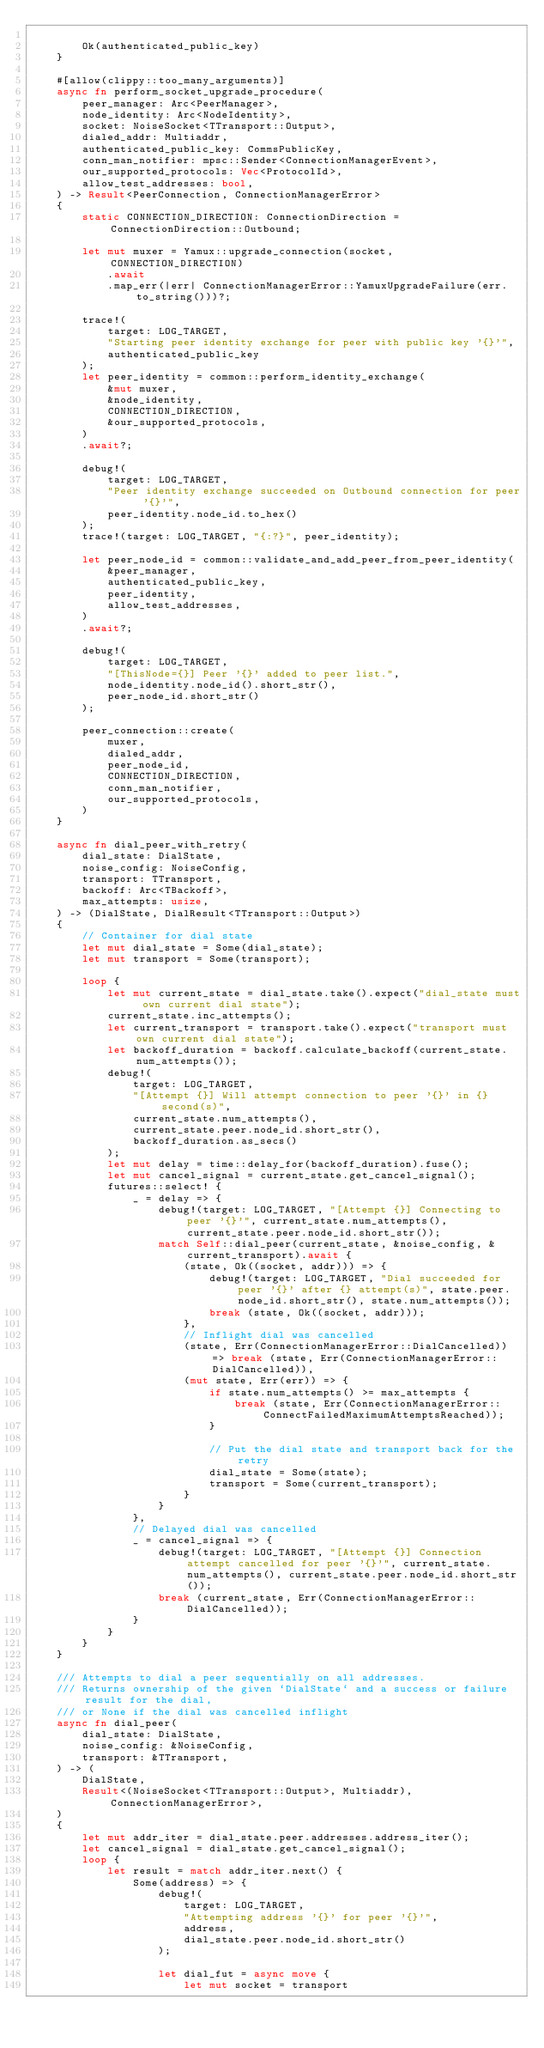<code> <loc_0><loc_0><loc_500><loc_500><_Rust_>
        Ok(authenticated_public_key)
    }

    #[allow(clippy::too_many_arguments)]
    async fn perform_socket_upgrade_procedure(
        peer_manager: Arc<PeerManager>,
        node_identity: Arc<NodeIdentity>,
        socket: NoiseSocket<TTransport::Output>,
        dialed_addr: Multiaddr,
        authenticated_public_key: CommsPublicKey,
        conn_man_notifier: mpsc::Sender<ConnectionManagerEvent>,
        our_supported_protocols: Vec<ProtocolId>,
        allow_test_addresses: bool,
    ) -> Result<PeerConnection, ConnectionManagerError>
    {
        static CONNECTION_DIRECTION: ConnectionDirection = ConnectionDirection::Outbound;

        let mut muxer = Yamux::upgrade_connection(socket, CONNECTION_DIRECTION)
            .await
            .map_err(|err| ConnectionManagerError::YamuxUpgradeFailure(err.to_string()))?;

        trace!(
            target: LOG_TARGET,
            "Starting peer identity exchange for peer with public key '{}'",
            authenticated_public_key
        );
        let peer_identity = common::perform_identity_exchange(
            &mut muxer,
            &node_identity,
            CONNECTION_DIRECTION,
            &our_supported_protocols,
        )
        .await?;

        debug!(
            target: LOG_TARGET,
            "Peer identity exchange succeeded on Outbound connection for peer '{}'",
            peer_identity.node_id.to_hex()
        );
        trace!(target: LOG_TARGET, "{:?}", peer_identity);

        let peer_node_id = common::validate_and_add_peer_from_peer_identity(
            &peer_manager,
            authenticated_public_key,
            peer_identity,
            allow_test_addresses,
        )
        .await?;

        debug!(
            target: LOG_TARGET,
            "[ThisNode={}] Peer '{}' added to peer list.",
            node_identity.node_id().short_str(),
            peer_node_id.short_str()
        );

        peer_connection::create(
            muxer,
            dialed_addr,
            peer_node_id,
            CONNECTION_DIRECTION,
            conn_man_notifier,
            our_supported_protocols,
        )
    }

    async fn dial_peer_with_retry(
        dial_state: DialState,
        noise_config: NoiseConfig,
        transport: TTransport,
        backoff: Arc<TBackoff>,
        max_attempts: usize,
    ) -> (DialState, DialResult<TTransport::Output>)
    {
        // Container for dial state
        let mut dial_state = Some(dial_state);
        let mut transport = Some(transport);

        loop {
            let mut current_state = dial_state.take().expect("dial_state must own current dial state");
            current_state.inc_attempts();
            let current_transport = transport.take().expect("transport must own current dial state");
            let backoff_duration = backoff.calculate_backoff(current_state.num_attempts());
            debug!(
                target: LOG_TARGET,
                "[Attempt {}] Will attempt connection to peer '{}' in {} second(s)",
                current_state.num_attempts(),
                current_state.peer.node_id.short_str(),
                backoff_duration.as_secs()
            );
            let mut delay = time::delay_for(backoff_duration).fuse();
            let mut cancel_signal = current_state.get_cancel_signal();
            futures::select! {
                _ = delay => {
                    debug!(target: LOG_TARGET, "[Attempt {}] Connecting to peer '{}'", current_state.num_attempts(), current_state.peer.node_id.short_str());
                    match Self::dial_peer(current_state, &noise_config, &current_transport).await {
                        (state, Ok((socket, addr))) => {
                            debug!(target: LOG_TARGET, "Dial succeeded for peer '{}' after {} attempt(s)", state.peer.node_id.short_str(), state.num_attempts());
                            break (state, Ok((socket, addr)));
                        },
                        // Inflight dial was cancelled
                        (state, Err(ConnectionManagerError::DialCancelled)) => break (state, Err(ConnectionManagerError::DialCancelled)),
                        (mut state, Err(err)) => {
                            if state.num_attempts() >= max_attempts {
                                break (state, Err(ConnectionManagerError::ConnectFailedMaximumAttemptsReached));
                            }

                            // Put the dial state and transport back for the retry
                            dial_state = Some(state);
                            transport = Some(current_transport);
                        }
                    }
                },
                // Delayed dial was cancelled
                _ = cancel_signal => {
                    debug!(target: LOG_TARGET, "[Attempt {}] Connection attempt cancelled for peer '{}'", current_state.num_attempts(), current_state.peer.node_id.short_str());
                    break (current_state, Err(ConnectionManagerError::DialCancelled));
                }
            }
        }
    }

    /// Attempts to dial a peer sequentially on all addresses.
    /// Returns ownership of the given `DialState` and a success or failure result for the dial,
    /// or None if the dial was cancelled inflight
    async fn dial_peer(
        dial_state: DialState,
        noise_config: &NoiseConfig,
        transport: &TTransport,
    ) -> (
        DialState,
        Result<(NoiseSocket<TTransport::Output>, Multiaddr), ConnectionManagerError>,
    )
    {
        let mut addr_iter = dial_state.peer.addresses.address_iter();
        let cancel_signal = dial_state.get_cancel_signal();
        loop {
            let result = match addr_iter.next() {
                Some(address) => {
                    debug!(
                        target: LOG_TARGET,
                        "Attempting address '{}' for peer '{}'",
                        address,
                        dial_state.peer.node_id.short_str()
                    );

                    let dial_fut = async move {
                        let mut socket = transport</code> 